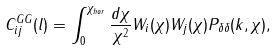<formula> <loc_0><loc_0><loc_500><loc_500>C _ { i j } ^ { G G } ( l ) = \int _ { 0 } ^ { \chi _ { h o r } } \frac { d \chi } { \chi ^ { 2 } } W _ { i } ( \chi ) W _ { j } ( \chi ) P _ { \delta \delta } ( k , \chi ) ,</formula> 